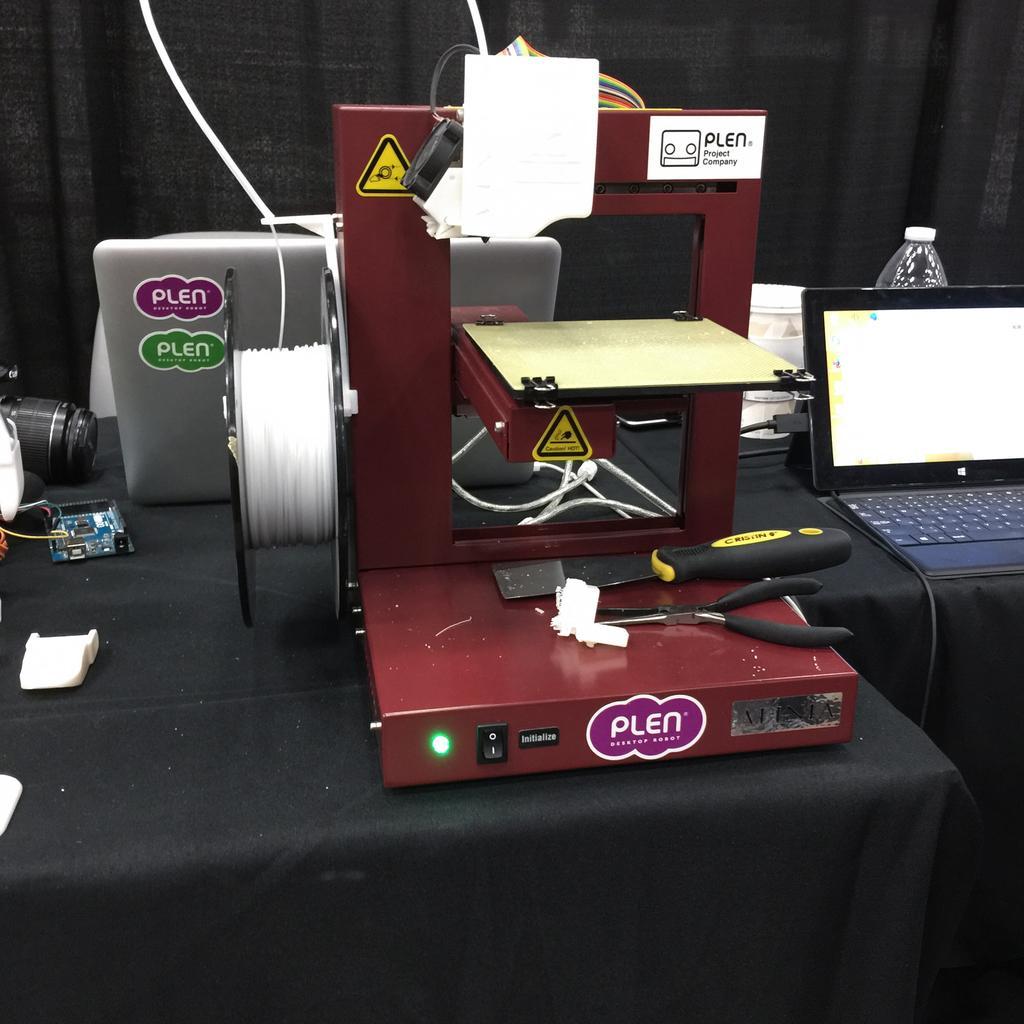In one or two sentences, can you explain what this image depicts? This image consists of a machine it is in brown color. On which we can see a cutting player. At the bottom, there is a black cloth on the table. At the bottom, there is a black cloth on the table. On the left, we can see a camera. On the right, there is a laptop and a bottle. In the background, there is a black cloth. 